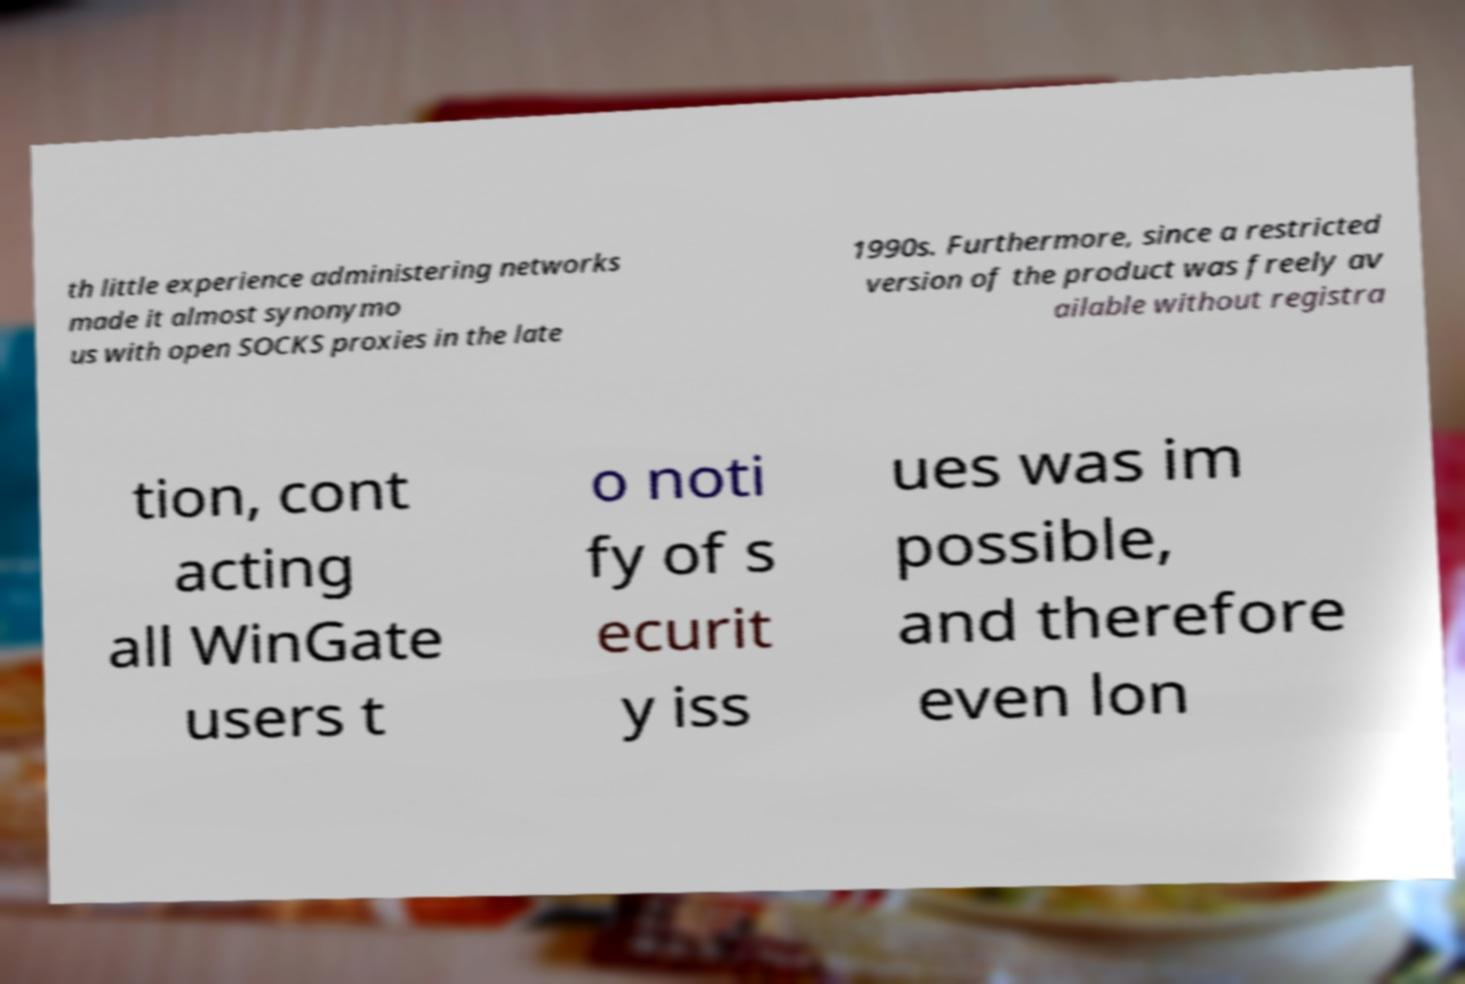Can you accurately transcribe the text from the provided image for me? th little experience administering networks made it almost synonymo us with open SOCKS proxies in the late 1990s. Furthermore, since a restricted version of the product was freely av ailable without registra tion, cont acting all WinGate users t o noti fy of s ecurit y iss ues was im possible, and therefore even lon 